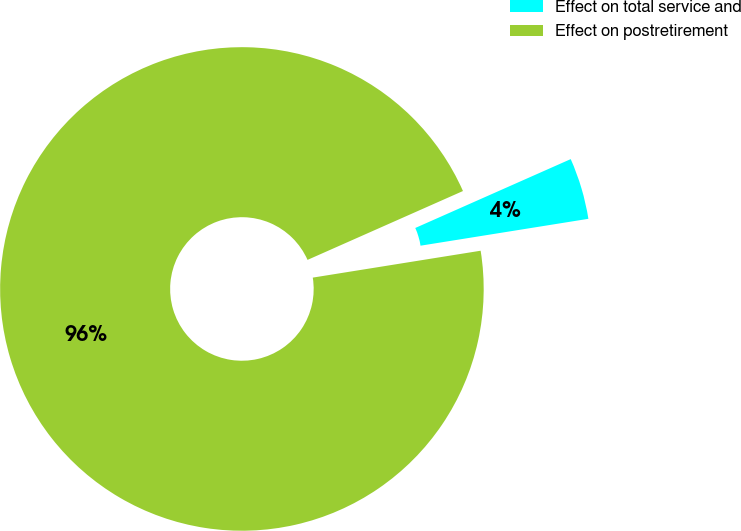Convert chart to OTSL. <chart><loc_0><loc_0><loc_500><loc_500><pie_chart><fcel>Effect on total service and<fcel>Effect on postretirement<nl><fcel>4.11%<fcel>95.89%<nl></chart> 